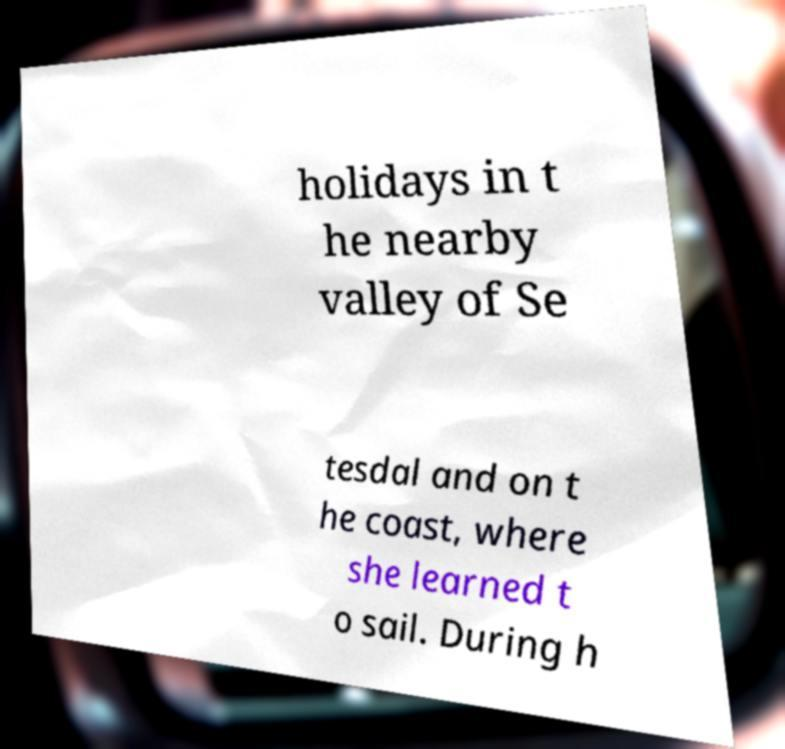Can you read and provide the text displayed in the image?This photo seems to have some interesting text. Can you extract and type it out for me? holidays in t he nearby valley of Se tesdal and on t he coast, where she learned t o sail. During h 